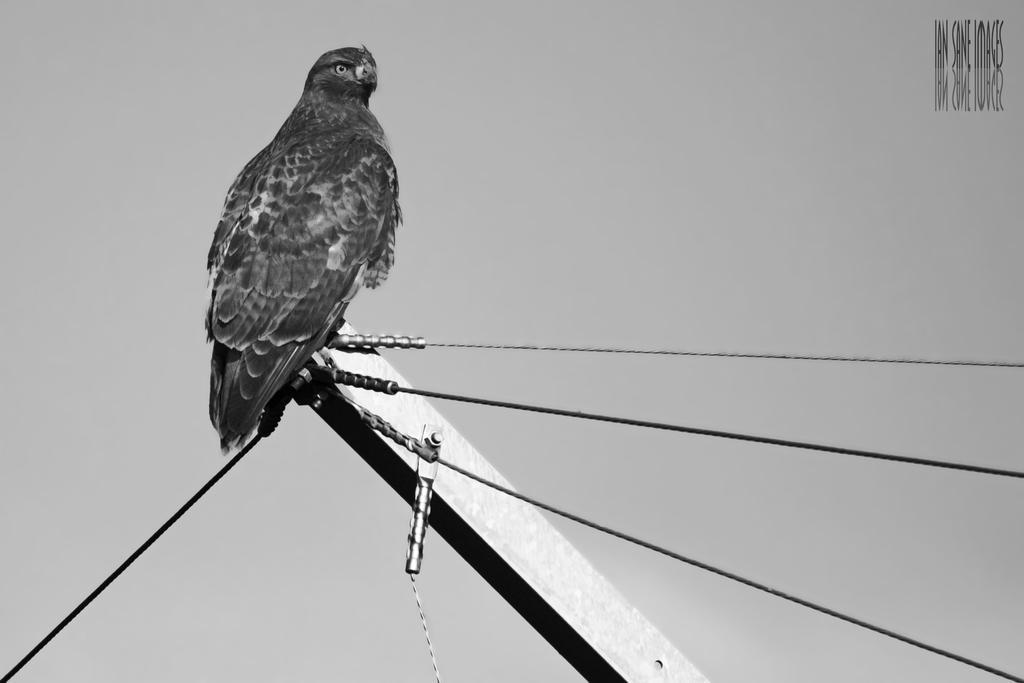Describe this image in one or two sentences. In this image there is a pole connected with wires. A bird is standing on the pole. Background there is sky. 